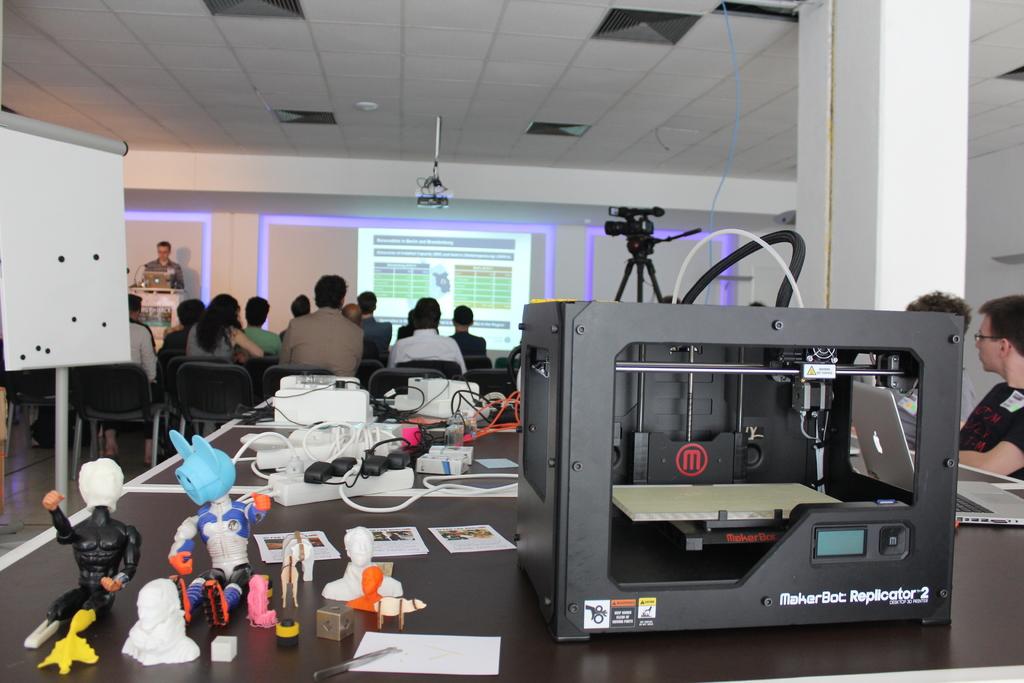What is the name of this 3d printer?
Offer a very short reply. Unanswerable. What color is the 3d printer on the table?
Your response must be concise. Answering does not require reading text in the image. 